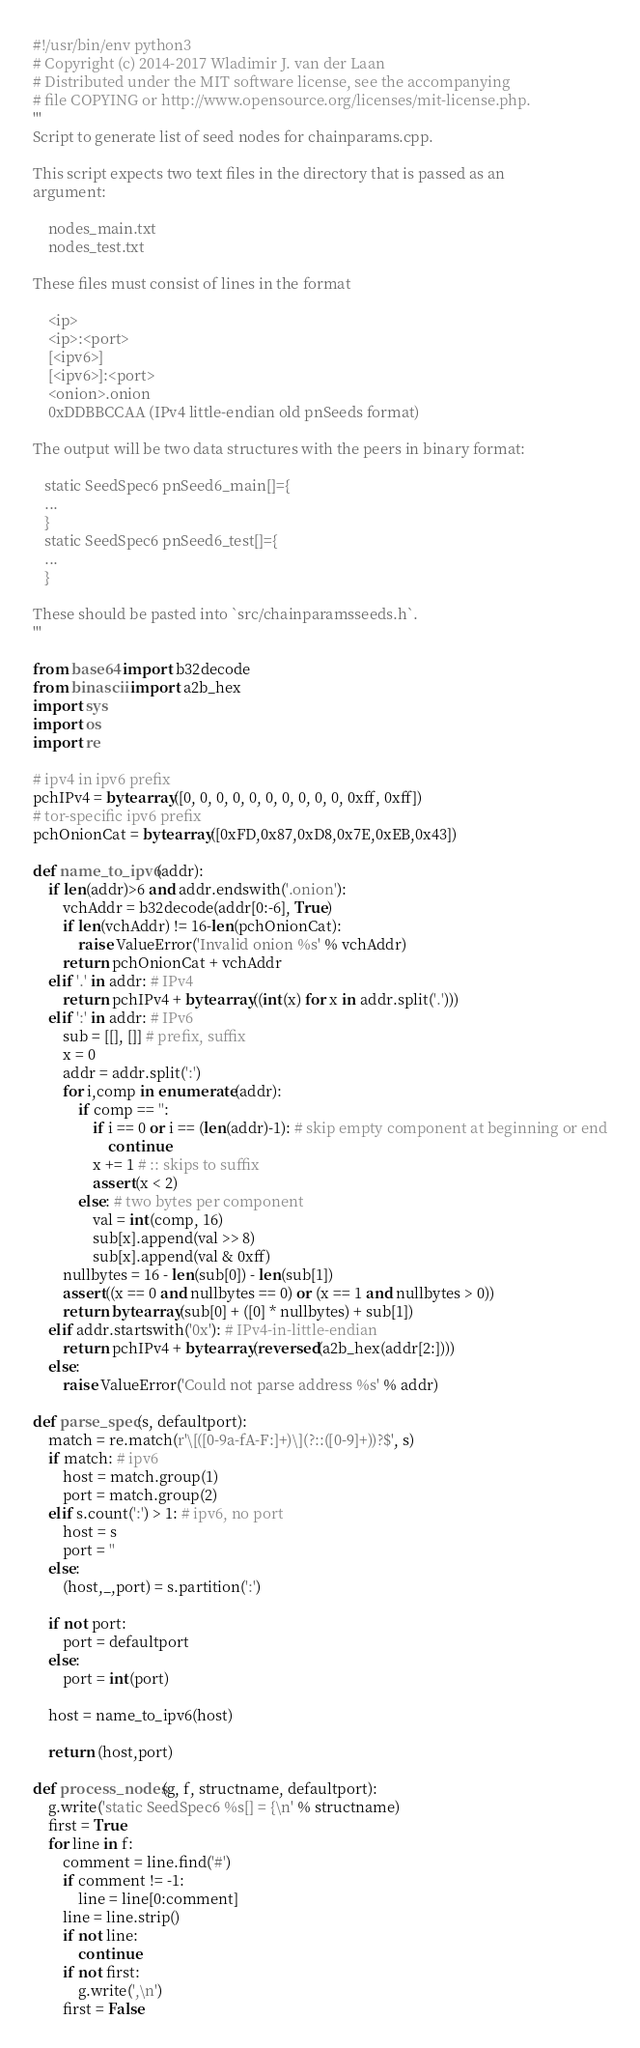<code> <loc_0><loc_0><loc_500><loc_500><_Python_>#!/usr/bin/env python3
# Copyright (c) 2014-2017 Wladimir J. van der Laan
# Distributed under the MIT software license, see the accompanying
# file COPYING or http://www.opensource.org/licenses/mit-license.php.
'''
Script to generate list of seed nodes for chainparams.cpp.

This script expects two text files in the directory that is passed as an
argument:

    nodes_main.txt
    nodes_test.txt

These files must consist of lines in the format

    <ip>
    <ip>:<port>
    [<ipv6>]
    [<ipv6>]:<port>
    <onion>.onion
    0xDDBBCCAA (IPv4 little-endian old pnSeeds format)

The output will be two data structures with the peers in binary format:

   static SeedSpec6 pnSeed6_main[]={
   ...
   }
   static SeedSpec6 pnSeed6_test[]={
   ...
   }

These should be pasted into `src/chainparamsseeds.h`.
'''

from base64 import b32decode
from binascii import a2b_hex
import sys
import os
import re

# ipv4 in ipv6 prefix
pchIPv4 = bytearray([0, 0, 0, 0, 0, 0, 0, 0, 0, 0, 0xff, 0xff])
# tor-specific ipv6 prefix
pchOnionCat = bytearray([0xFD,0x87,0xD8,0x7E,0xEB,0x43])

def name_to_ipv6(addr):
    if len(addr)>6 and addr.endswith('.onion'):
        vchAddr = b32decode(addr[0:-6], True)
        if len(vchAddr) != 16-len(pchOnionCat):
            raise ValueError('Invalid onion %s' % vchAddr)
        return pchOnionCat + vchAddr
    elif '.' in addr: # IPv4
        return pchIPv4 + bytearray((int(x) for x in addr.split('.')))
    elif ':' in addr: # IPv6
        sub = [[], []] # prefix, suffix
        x = 0
        addr = addr.split(':')
        for i,comp in enumerate(addr):
            if comp == '':
                if i == 0 or i == (len(addr)-1): # skip empty component at beginning or end
                    continue
                x += 1 # :: skips to suffix
                assert(x < 2)
            else: # two bytes per component
                val = int(comp, 16)
                sub[x].append(val >> 8)
                sub[x].append(val & 0xff)
        nullbytes = 16 - len(sub[0]) - len(sub[1])
        assert((x == 0 and nullbytes == 0) or (x == 1 and nullbytes > 0))
        return bytearray(sub[0] + ([0] * nullbytes) + sub[1])
    elif addr.startswith('0x'): # IPv4-in-little-endian
        return pchIPv4 + bytearray(reversed(a2b_hex(addr[2:])))
    else:
        raise ValueError('Could not parse address %s' % addr)

def parse_spec(s, defaultport):
    match = re.match(r'\[([0-9a-fA-F:]+)\](?::([0-9]+))?$', s)
    if match: # ipv6
        host = match.group(1)
        port = match.group(2)
    elif s.count(':') > 1: # ipv6, no port
        host = s
        port = ''
    else:
        (host,_,port) = s.partition(':')

    if not port:
        port = defaultport
    else:
        port = int(port)

    host = name_to_ipv6(host)

    return (host,port)

def process_nodes(g, f, structname, defaultport):
    g.write('static SeedSpec6 %s[] = {\n' % structname)
    first = True
    for line in f:
        comment = line.find('#')
        if comment != -1:
            line = line[0:comment]
        line = line.strip()
        if not line:
            continue
        if not first:
            g.write(',\n')
        first = False
</code> 